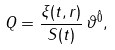<formula> <loc_0><loc_0><loc_500><loc_500>Q = \frac { \xi ( t , r ) } { S ( t ) } \, \vartheta ^ { \hat { 0 } } ,</formula> 